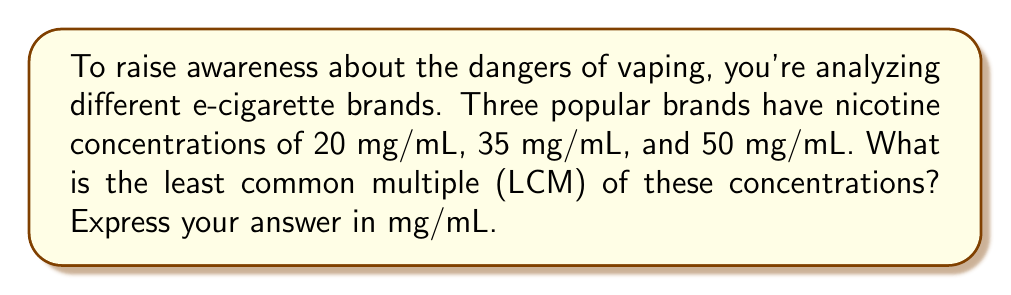Show me your answer to this math problem. To find the LCM of 20, 35, and 50 mg/mL, we'll follow these steps:

1) First, let's find the prime factorization of each number:
   
   $20 = 2^2 \times 5$
   $35 = 5 \times 7$
   $50 = 2 \times 5^2$

2) The LCM will include the highest power of each prime factor from these factorizations:

   - For 2: the highest power is 2 (from 20)
   - For 5: the highest power is 2 (from 50)
   - For 7: the highest power is 1 (from 35)

3) Therefore, the LCM is:

   $LCM = 2^2 \times 5^2 \times 7$

4) Let's calculate this:

   $LCM = 4 \times 25 \times 7 = 700$

Thus, the least common multiple of the nicotine concentrations is 700 mg/mL.
Answer: 700 mg/mL 